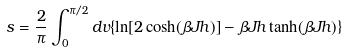<formula> <loc_0><loc_0><loc_500><loc_500>s = \frac { 2 } { \pi } \int _ { 0 } ^ { \pi / 2 } d v \{ \ln [ 2 \cosh ( \beta J h ) ] - \beta J h \tanh ( \beta J h ) \}</formula> 